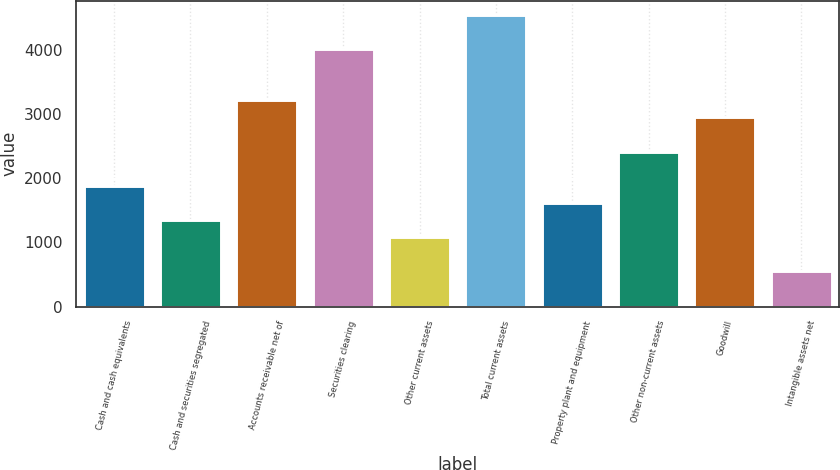Convert chart to OTSL. <chart><loc_0><loc_0><loc_500><loc_500><bar_chart><fcel>Cash and cash equivalents<fcel>Cash and securities segregated<fcel>Accounts receivable net of<fcel>Securities clearing<fcel>Other current assets<fcel>Total current assets<fcel>Property plant and equipment<fcel>Other non-current assets<fcel>Goodwill<fcel>Intangible assets net<nl><fcel>1882.12<fcel>1351.4<fcel>3208.92<fcel>4005<fcel>1086.04<fcel>4535.72<fcel>1616.76<fcel>2412.84<fcel>2943.56<fcel>555.32<nl></chart> 